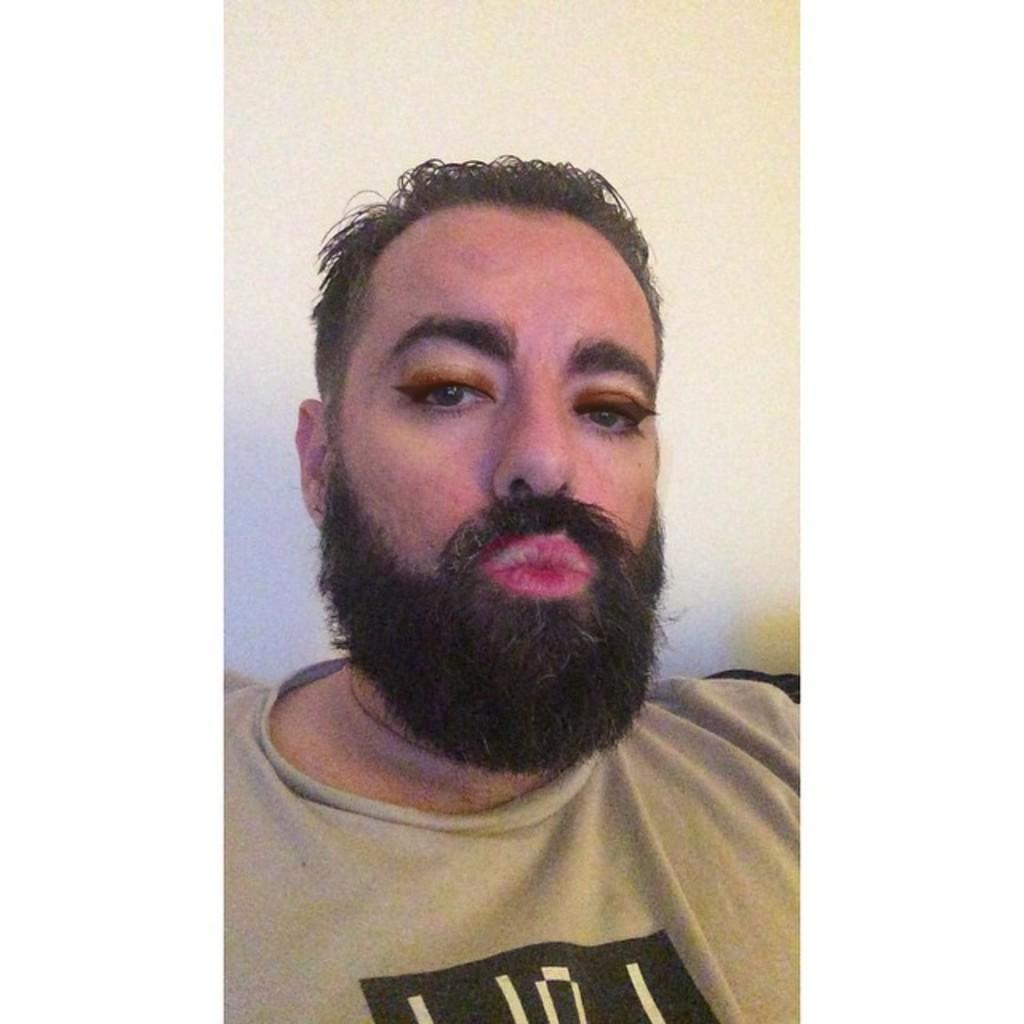What is the man in the image doing? The man is sitting in the image. Can you describe the man's appearance? The man has a beard. What is the man using in the image? The man is using a makeup filter. What can be seen in the background of the image? There is a white wall in the background of the image. What type of lettuce is growing in the cemetery in the image? There is no lettuce or cemetery present in the image; it features a man sitting with a beard and using a makeup filter in front of a white wall. 